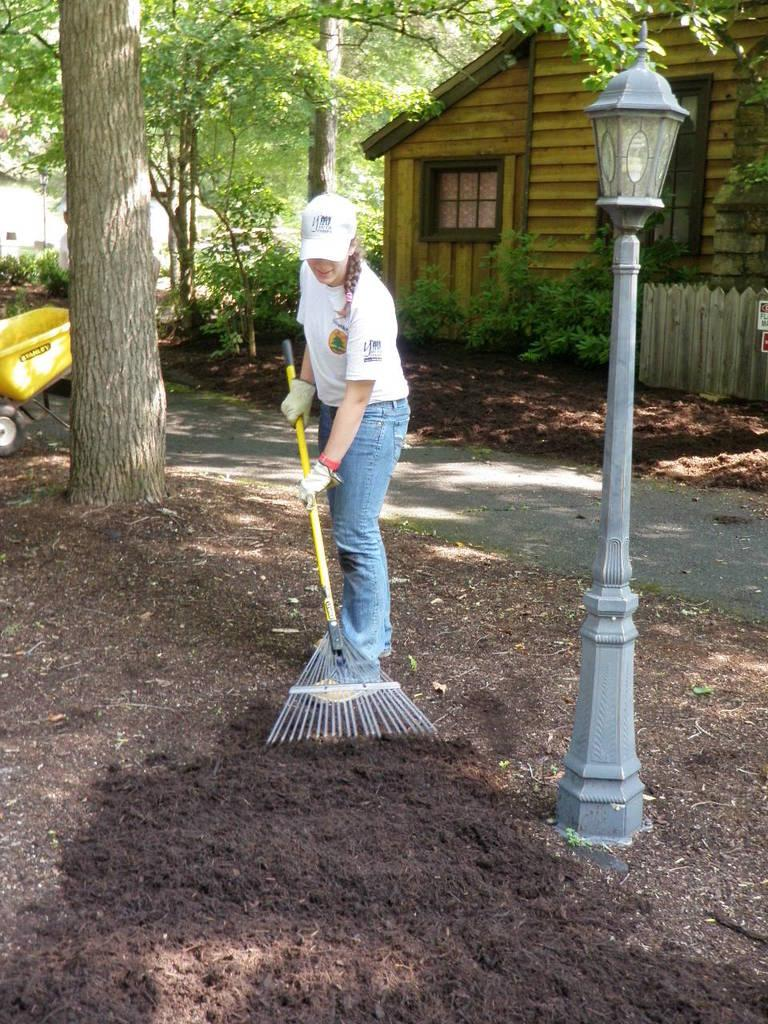What is the main subject of the image? There is a person in the image. Can you describe the person's clothing? The person is wearing a white shirt and blue pants. What is the person holding in the image? The person is holding a stick. What can be seen in the background of the image? There is a house and trees in the background of the image. Can you describe the house and trees? The house is brown, and the trees are green. How many oranges are hanging from the trees in the image? There are no oranges visible in the image; only green trees are present. What type of cannon is located near the house in the image? There is no cannon present in the image; only a person, a stick, a light pole, a house, and trees are visible. 